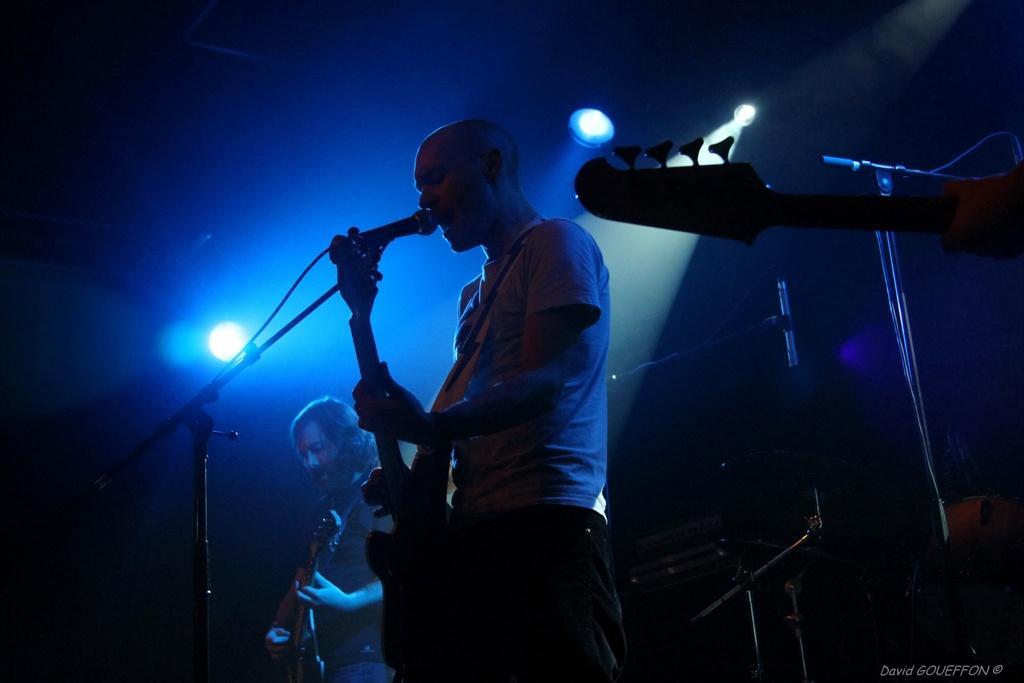Can you describe this image briefly? The two persons are standing on a stage. They are playing a musical instruments. We can see in the background there is a light. 